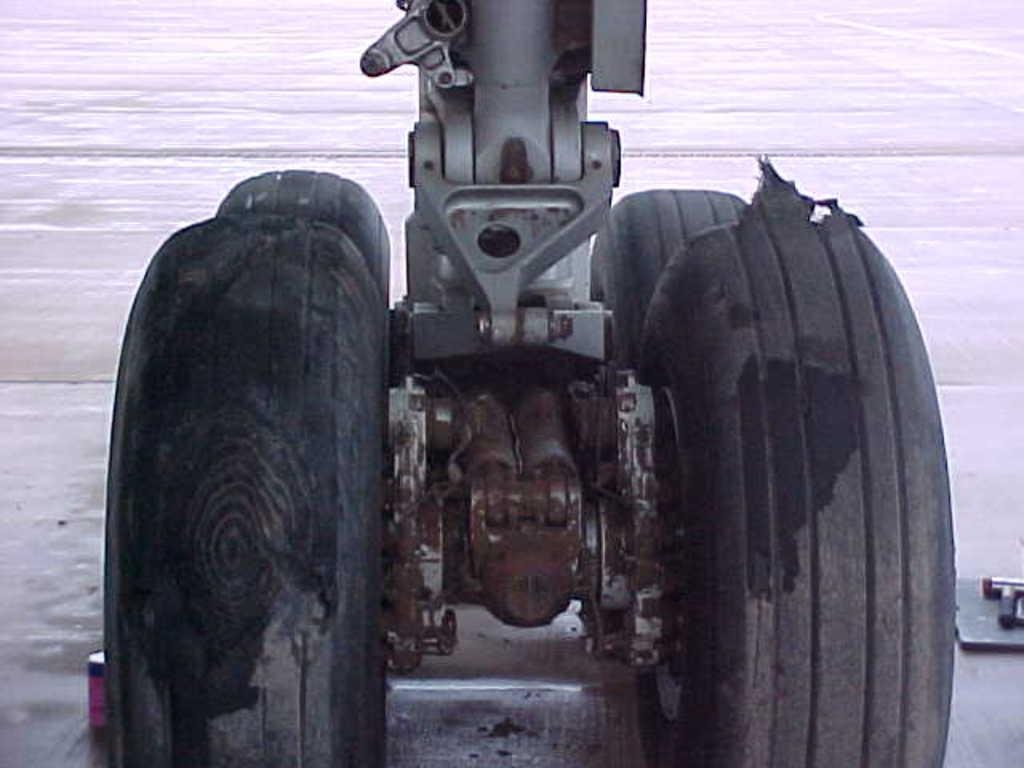What objects in the image have wheels? The facts do not specify what objects have wheels, but we know that there are wheels in the image. What color are the wheels? The wheels are black in color. What is the color of the background in the image? The background of the image is white. What type of glue is being used by the secretary in the image? There is no secretary or glue present in the image; it only features black wheels and a white background. 